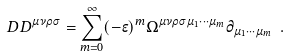Convert formula to latex. <formula><loc_0><loc_0><loc_500><loc_500>\ D D ^ { \mu \nu \rho \sigma } = \sum _ { m = 0 } ^ { \infty } ( - \epsilon ) ^ { m } \Omega ^ { \mu \nu \rho \sigma \mu _ { 1 } \cdots \mu _ { m } } \partial _ { \mu _ { 1 } \cdots \mu _ { m } } \ .</formula> 